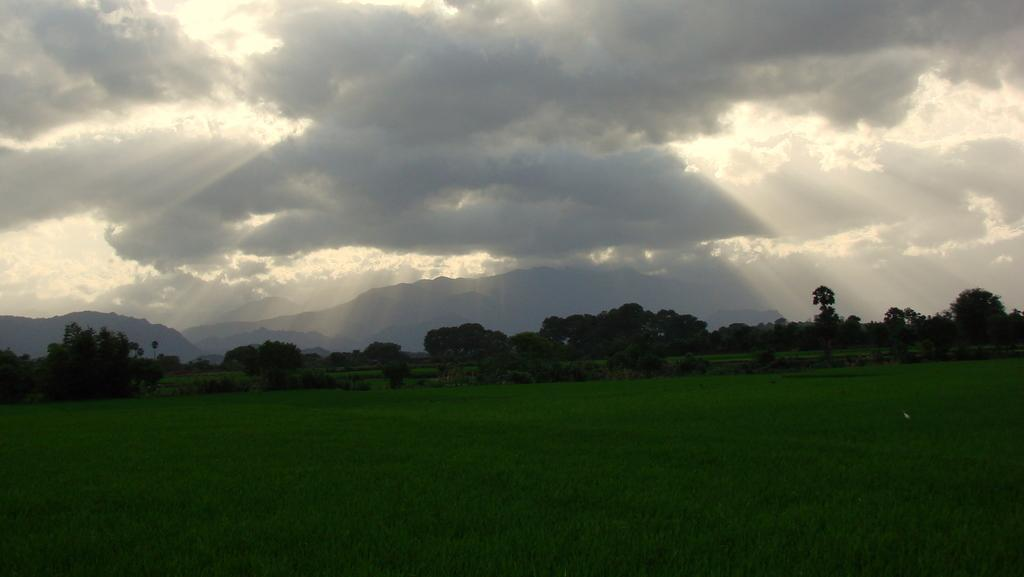What type of vegetation is at the bottom of the picture? There is grass in green color at the bottom of the picture. What can be seen in the background of the image? There are many trees and hills in the background. What is visible at the top of the picture? The sky is visible at the top of the picture. What can be observed in the sky? Clouds are present in the sky. What type of thread is used to create the door in the image? There is no door present in the image; it features grass, trees, hills, and clouds. 